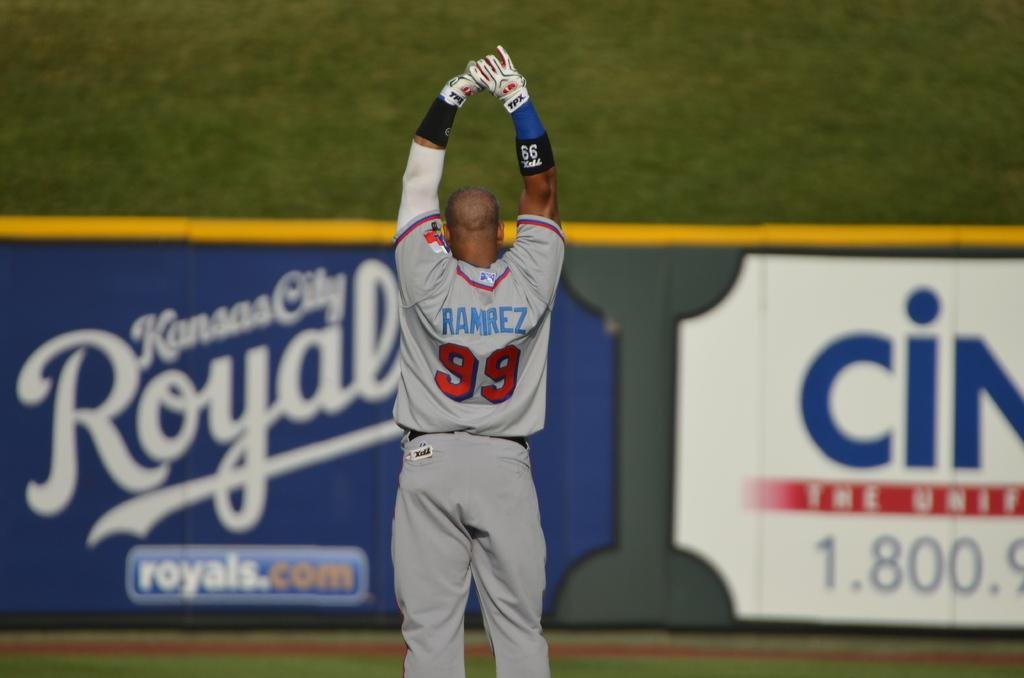<image>
Render a clear and concise summary of the photo. an image of a baseball player named Ramirez with the number 99, standing in a baseball field with his arms up. 